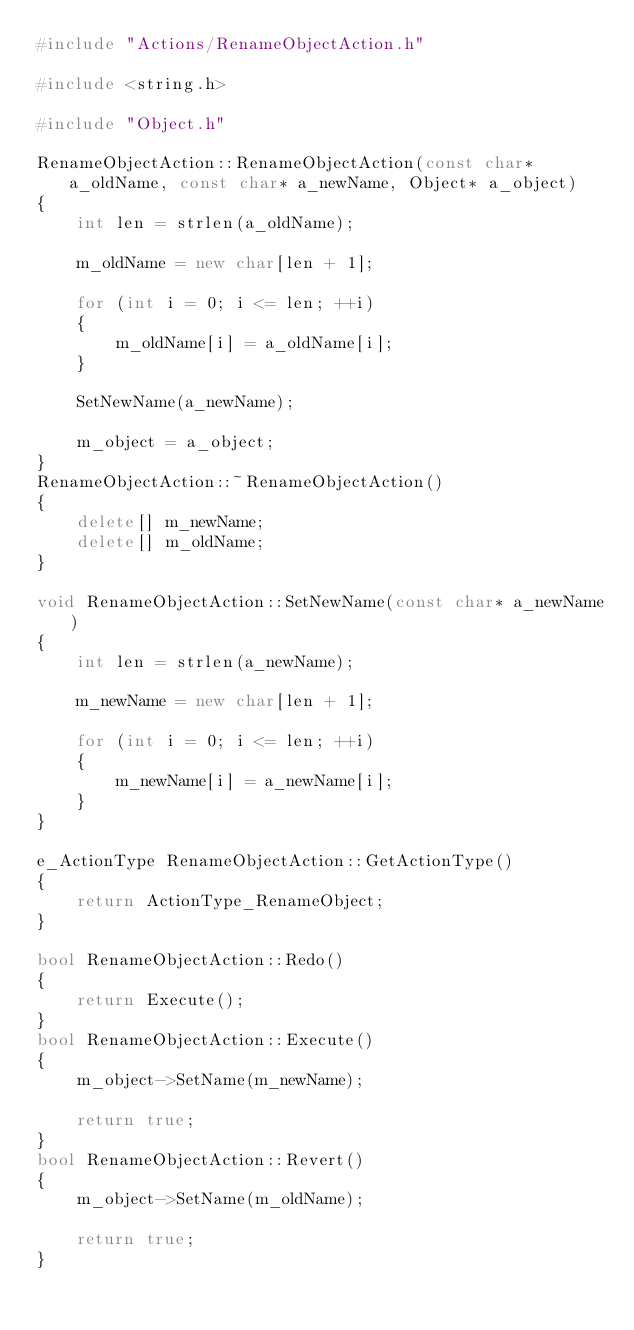<code> <loc_0><loc_0><loc_500><loc_500><_C++_>#include "Actions/RenameObjectAction.h"

#include <string.h>

#include "Object.h"

RenameObjectAction::RenameObjectAction(const char* a_oldName, const char* a_newName, Object* a_object)
{
    int len = strlen(a_oldName);

    m_oldName = new char[len + 1];

    for (int i = 0; i <= len; ++i)
    {
        m_oldName[i] = a_oldName[i];
    }

    SetNewName(a_newName);

    m_object = a_object;
}
RenameObjectAction::~RenameObjectAction()
{
    delete[] m_newName;
    delete[] m_oldName;
}

void RenameObjectAction::SetNewName(const char* a_newName)
{
    int len = strlen(a_newName);

    m_newName = new char[len + 1];

    for (int i = 0; i <= len; ++i)
    {
        m_newName[i] = a_newName[i];
    }
}

e_ActionType RenameObjectAction::GetActionType() 
{
    return ActionType_RenameObject;
}

bool RenameObjectAction::Redo()
{
    return Execute();
}
bool RenameObjectAction::Execute()
{
    m_object->SetName(m_newName);

    return true;
}
bool RenameObjectAction::Revert()
{
    m_object->SetName(m_oldName);

    return true;
}</code> 